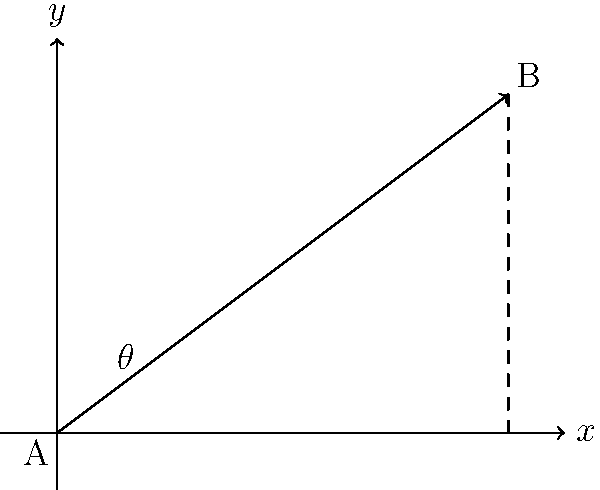As a basketball player, you're practicing passing drills with your teammate. You're at point A(0,0) and your teammate is at point B(8,6) on a coordinate plane measured in meters. What is the optimal passing angle $\theta$ (in degrees) from the positive x-axis for an accurate pass? To find the optimal passing angle, we need to use the arctangent function with the vector components. Let's approach this step-by-step:

1) The vector from point A to point B is $\vec{AB} = (8, 6)$.

2) The components of this vector represent the change in x and y:
   $\Delta x = 8$ meters
   $\Delta y = 6$ meters

3) The optimal passing angle $\theta$ is the angle this vector makes with the positive x-axis.

4) We can calculate this angle using the arctangent function:

   $\theta = \arctan(\frac{\Delta y}{\Delta x})$

5) Substituting our values:

   $\theta = \arctan(\frac{6}{8})$

6) Simplifying:

   $\theta = \arctan(0.75)$

7) Using a calculator or computer:

   $\theta \approx 36.87°$

8) Rounding to the nearest degree:

   $\theta \approx 37°$

This angle represents the optimal direction for your pass to reach your teammate accurately.
Answer: 37° 